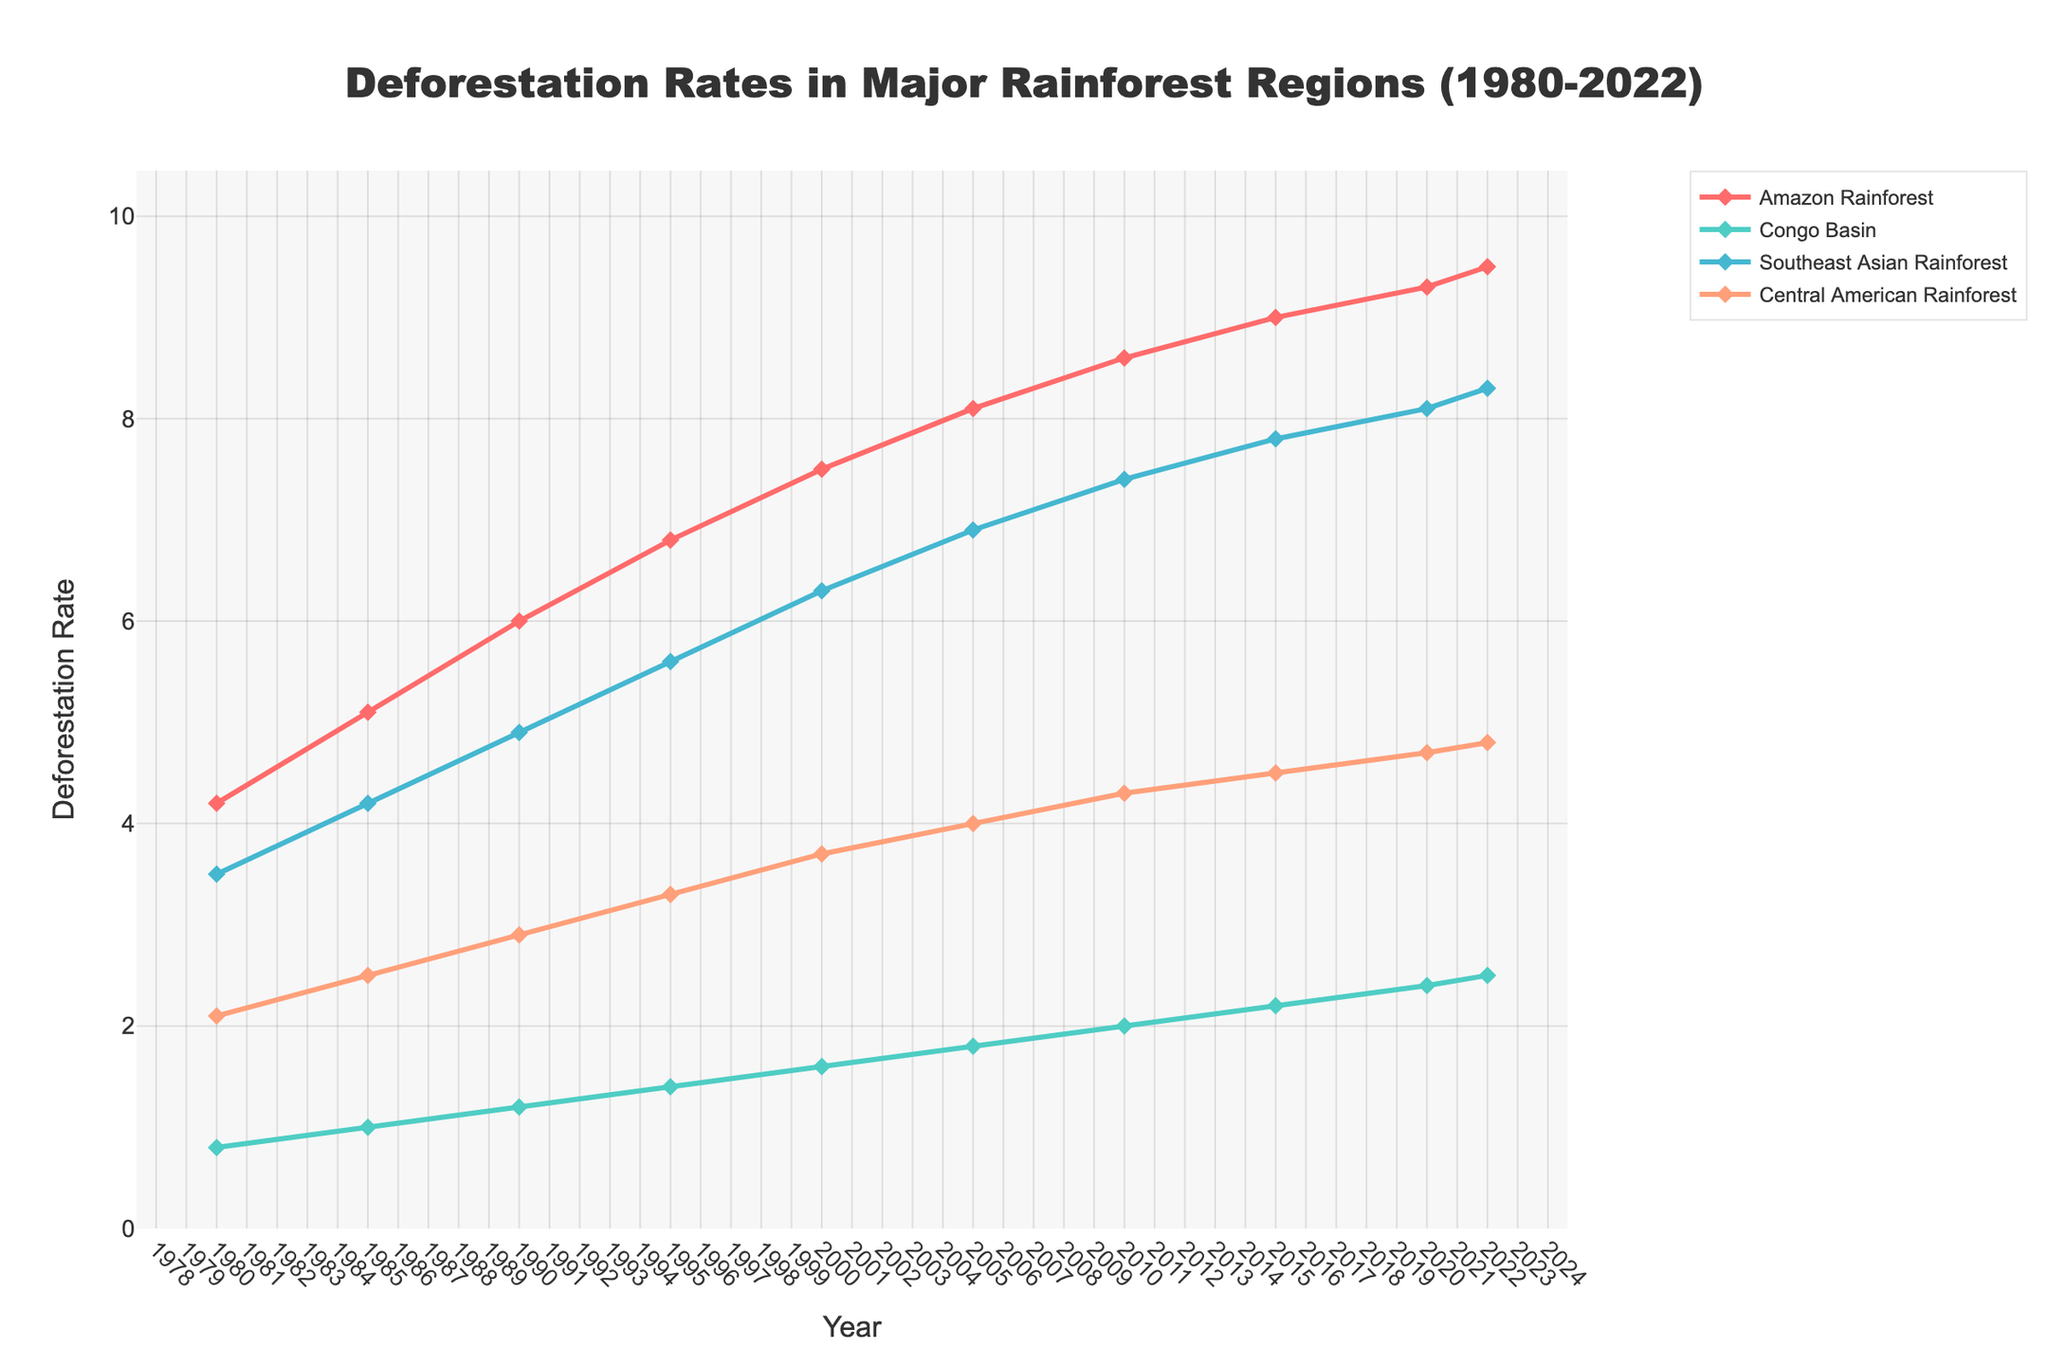Which rainforest region had the highest deforestation rate in 2022? The plot shows that in 2022, the Amazon Rainforest had the highest deforestation rate among the given regions.
Answer: Amazon Rainforest How did the deforestation rate in the Congo Basin change from 1980 to 2022? In the plot, the deforestation rate in the Congo Basin rises gradually from 0.8 in 1980 to 2.5 in 2022. The change is calculated as 2.5 - 0.8 = 1.7.
Answer: Increased by 1.7 What was the average deforestation rate for the Amazon Rainforest from 1980 to 2022? Sum the rates for the Amazon Rainforest: 4.2 + 5.1 + 6.0 + 6.8 + 7.5 + 8.1 + 8.6 + 9.0 + 9.3 + 9.5 = 74.1. There are 10 years, so the average is 74.1 / 10.
Answer: 7.41 Which region experienced the fastest increase in deforestation rate between 1980 and 2022? To determine this, examine the slopes of each region’s line on the plot. The Amazon Rainforest line shows the steepest increase from 4.2 to 9.5, a change of 5.3.
Answer: Amazon Rainforest In which year did the Central American Rainforest's deforestation rate surpass 4.0? Checking the plot, the deforestation rate for Central American Rainforest first surpasses 4.0 in the year 2005.
Answer: 2005 What’s the difference in deforestation rate between the Amazon Rainforest and the Southeast Asian Rainforest in 1990? The plot indicates that in 1990, the Amazon Rainforest had a rate of 6.0 and Southeast Asian Rainforest had 4.9. The difference is 6.0 - 4.9.
Answer: 1.1 By how much did the deforestation rate in Southeast Asian Rainforest increase from 1980 to 2000? From the plot, the deforestation rate in Southeast Asian Rainforest increased from 3.5 in 1980 to 6.3 in 2000. The increase is calculated as 6.3 - 3.5.
Answer: 2.8 Compare the deforestation rate trends for the Amazon Rainforest and Congo Basin between 1980 and 2022. Both regions’ deforestation rates increased, but the Amazon Rainforest's rate increased more significantly from 4.2 to 9.5, while the Congo Basin’s rate rose from 0.8 to 2.5, representing smaller increments.
Answer: Amazon Rainforest increased more Which region showed a steady increase in deforestation rate without any years of decline or plateau from 1980 to 2022? Examining the plot visually, the deforestation rate in the Southeast Asian Rainforest shows a steady increase every year without any decline or plateau.
Answer: Southeast Asian Rainforest What year did Amazon Rainforest’s deforestation rate reach 7.5? From the plot, the deforestation rate for the Amazon Rainforest reaches 7.5 in the year 2000.
Answer: 2000 